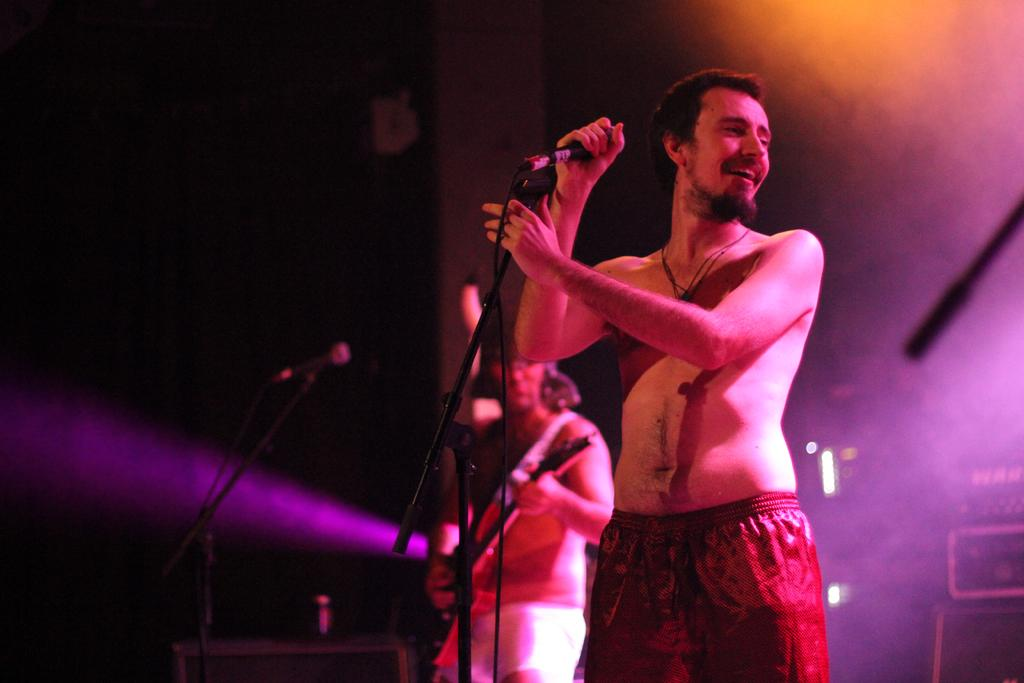What is the man in the image holding? The man is holding a microphone in the image. What is the man's facial expression in the image? The man is smiling in the image. What is another person in the image doing? There is a person playing a guitar in the image. What can be seen providing illumination in the image? There is a light visible in the image. What type of fish can be seen swimming in the image? There are no fish present in the image. Can you describe the playground equipment visible in the image? There is no playground equipment visible in the image. 